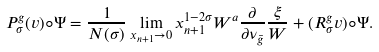<formula> <loc_0><loc_0><loc_500><loc_500>P ^ { g } _ { \sigma } ( v ) \circ \Psi = \frac { 1 } { N ( \sigma ) } \lim _ { x _ { n + 1 } \to 0 } x _ { n + 1 } ^ { 1 - 2 \sigma } W ^ { a } \frac { \partial } { \partial \nu _ { \bar { g } } } \frac { \xi } { W } + ( R _ { \sigma } ^ { g } v ) \circ \Psi .</formula> 